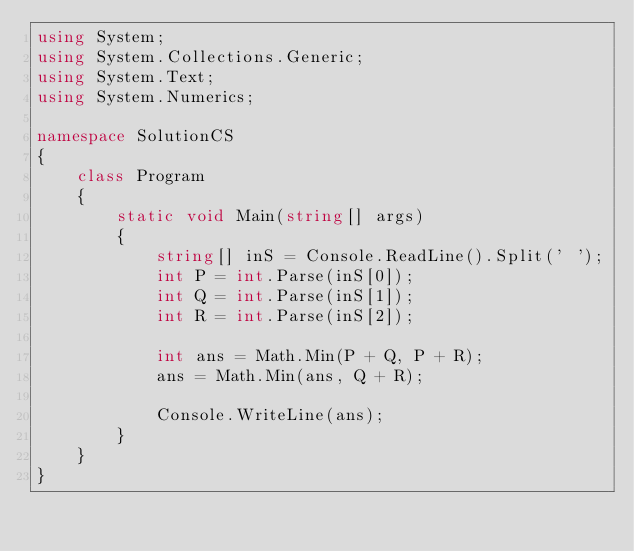<code> <loc_0><loc_0><loc_500><loc_500><_C#_>using System;
using System.Collections.Generic;
using System.Text;
using System.Numerics;

namespace SolutionCS
{
    class Program
    {
        static void Main(string[] args)
        {
            string[] inS = Console.ReadLine().Split(' ');
            int P = int.Parse(inS[0]);
            int Q = int.Parse(inS[1]);
            int R = int.Parse(inS[2]);

            int ans = Math.Min(P + Q, P + R);
            ans = Math.Min(ans, Q + R);

            Console.WriteLine(ans);
        }
    }
}
</code> 